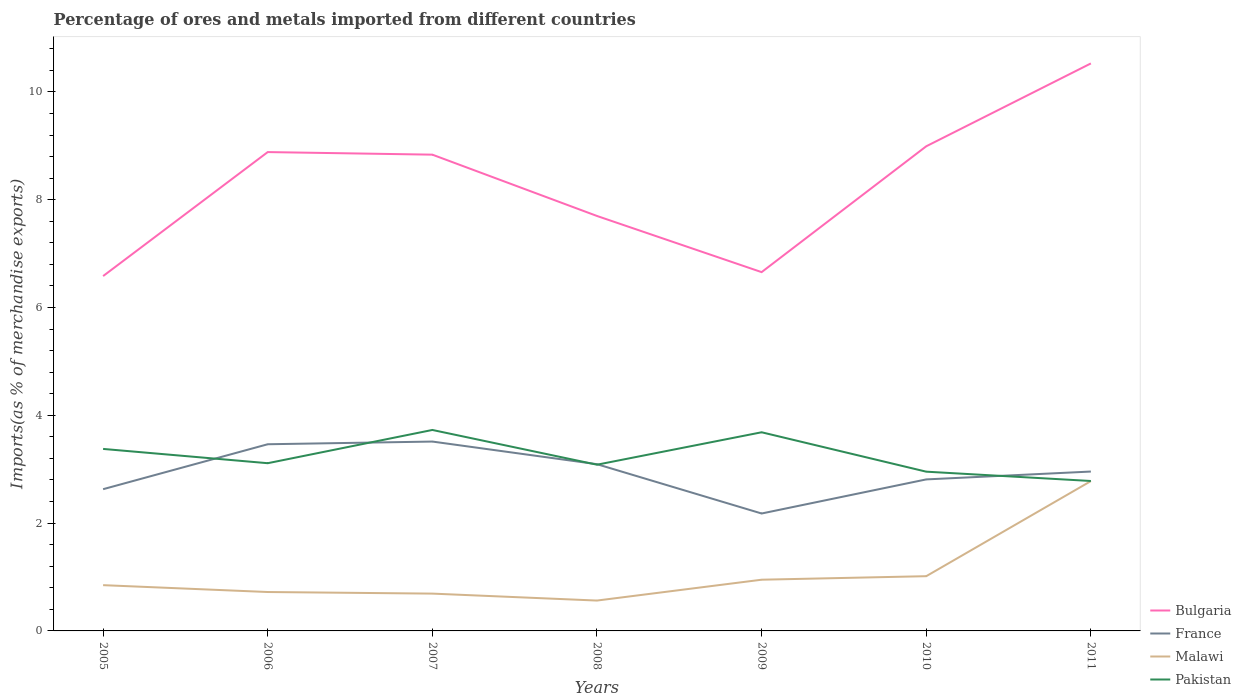How many different coloured lines are there?
Keep it short and to the point. 4. Across all years, what is the maximum percentage of imports to different countries in France?
Provide a succinct answer. 2.18. In which year was the percentage of imports to different countries in France maximum?
Make the answer very short. 2009. What is the total percentage of imports to different countries in France in the graph?
Ensure brevity in your answer.  0.37. What is the difference between the highest and the second highest percentage of imports to different countries in Bulgaria?
Provide a succinct answer. 3.94. Is the percentage of imports to different countries in Malawi strictly greater than the percentage of imports to different countries in Pakistan over the years?
Offer a terse response. Yes. How many lines are there?
Your answer should be compact. 4. How many years are there in the graph?
Your answer should be compact. 7. What is the difference between two consecutive major ticks on the Y-axis?
Your answer should be very brief. 2. Does the graph contain any zero values?
Give a very brief answer. No. How many legend labels are there?
Your answer should be compact. 4. How are the legend labels stacked?
Offer a very short reply. Vertical. What is the title of the graph?
Provide a short and direct response. Percentage of ores and metals imported from different countries. What is the label or title of the X-axis?
Make the answer very short. Years. What is the label or title of the Y-axis?
Offer a very short reply. Imports(as % of merchandise exports). What is the Imports(as % of merchandise exports) of Bulgaria in 2005?
Offer a terse response. 6.58. What is the Imports(as % of merchandise exports) of France in 2005?
Provide a succinct answer. 2.63. What is the Imports(as % of merchandise exports) in Malawi in 2005?
Offer a very short reply. 0.85. What is the Imports(as % of merchandise exports) of Pakistan in 2005?
Your answer should be compact. 3.38. What is the Imports(as % of merchandise exports) in Bulgaria in 2006?
Keep it short and to the point. 8.88. What is the Imports(as % of merchandise exports) of France in 2006?
Make the answer very short. 3.46. What is the Imports(as % of merchandise exports) of Malawi in 2006?
Offer a very short reply. 0.72. What is the Imports(as % of merchandise exports) of Pakistan in 2006?
Your answer should be very brief. 3.11. What is the Imports(as % of merchandise exports) in Bulgaria in 2007?
Offer a very short reply. 8.84. What is the Imports(as % of merchandise exports) of France in 2007?
Provide a succinct answer. 3.51. What is the Imports(as % of merchandise exports) in Malawi in 2007?
Ensure brevity in your answer.  0.69. What is the Imports(as % of merchandise exports) in Pakistan in 2007?
Keep it short and to the point. 3.73. What is the Imports(as % of merchandise exports) in Bulgaria in 2008?
Give a very brief answer. 7.7. What is the Imports(as % of merchandise exports) in France in 2008?
Give a very brief answer. 3.09. What is the Imports(as % of merchandise exports) of Malawi in 2008?
Offer a very short reply. 0.56. What is the Imports(as % of merchandise exports) of Pakistan in 2008?
Give a very brief answer. 3.08. What is the Imports(as % of merchandise exports) of Bulgaria in 2009?
Your response must be concise. 6.66. What is the Imports(as % of merchandise exports) in France in 2009?
Offer a terse response. 2.18. What is the Imports(as % of merchandise exports) in Malawi in 2009?
Keep it short and to the point. 0.95. What is the Imports(as % of merchandise exports) of Pakistan in 2009?
Ensure brevity in your answer.  3.69. What is the Imports(as % of merchandise exports) in Bulgaria in 2010?
Ensure brevity in your answer.  8.99. What is the Imports(as % of merchandise exports) in France in 2010?
Ensure brevity in your answer.  2.81. What is the Imports(as % of merchandise exports) of Malawi in 2010?
Provide a short and direct response. 1.02. What is the Imports(as % of merchandise exports) of Pakistan in 2010?
Offer a terse response. 2.95. What is the Imports(as % of merchandise exports) of Bulgaria in 2011?
Offer a terse response. 10.53. What is the Imports(as % of merchandise exports) of France in 2011?
Offer a terse response. 2.96. What is the Imports(as % of merchandise exports) in Malawi in 2011?
Your answer should be compact. 2.78. What is the Imports(as % of merchandise exports) in Pakistan in 2011?
Make the answer very short. 2.78. Across all years, what is the maximum Imports(as % of merchandise exports) in Bulgaria?
Your answer should be compact. 10.53. Across all years, what is the maximum Imports(as % of merchandise exports) in France?
Your answer should be compact. 3.51. Across all years, what is the maximum Imports(as % of merchandise exports) of Malawi?
Keep it short and to the point. 2.78. Across all years, what is the maximum Imports(as % of merchandise exports) in Pakistan?
Your response must be concise. 3.73. Across all years, what is the minimum Imports(as % of merchandise exports) in Bulgaria?
Offer a terse response. 6.58. Across all years, what is the minimum Imports(as % of merchandise exports) of France?
Offer a very short reply. 2.18. Across all years, what is the minimum Imports(as % of merchandise exports) in Malawi?
Ensure brevity in your answer.  0.56. Across all years, what is the minimum Imports(as % of merchandise exports) in Pakistan?
Provide a succinct answer. 2.78. What is the total Imports(as % of merchandise exports) of Bulgaria in the graph?
Your response must be concise. 58.18. What is the total Imports(as % of merchandise exports) in France in the graph?
Ensure brevity in your answer.  20.64. What is the total Imports(as % of merchandise exports) in Malawi in the graph?
Keep it short and to the point. 7.57. What is the total Imports(as % of merchandise exports) of Pakistan in the graph?
Give a very brief answer. 22.72. What is the difference between the Imports(as % of merchandise exports) in Bulgaria in 2005 and that in 2006?
Make the answer very short. -2.3. What is the difference between the Imports(as % of merchandise exports) in France in 2005 and that in 2006?
Provide a succinct answer. -0.83. What is the difference between the Imports(as % of merchandise exports) of Malawi in 2005 and that in 2006?
Your response must be concise. 0.13. What is the difference between the Imports(as % of merchandise exports) in Pakistan in 2005 and that in 2006?
Offer a terse response. 0.27. What is the difference between the Imports(as % of merchandise exports) of Bulgaria in 2005 and that in 2007?
Your answer should be compact. -2.25. What is the difference between the Imports(as % of merchandise exports) of France in 2005 and that in 2007?
Ensure brevity in your answer.  -0.88. What is the difference between the Imports(as % of merchandise exports) in Malawi in 2005 and that in 2007?
Ensure brevity in your answer.  0.16. What is the difference between the Imports(as % of merchandise exports) in Pakistan in 2005 and that in 2007?
Offer a very short reply. -0.35. What is the difference between the Imports(as % of merchandise exports) in Bulgaria in 2005 and that in 2008?
Your response must be concise. -1.11. What is the difference between the Imports(as % of merchandise exports) of France in 2005 and that in 2008?
Offer a very short reply. -0.46. What is the difference between the Imports(as % of merchandise exports) of Malawi in 2005 and that in 2008?
Keep it short and to the point. 0.29. What is the difference between the Imports(as % of merchandise exports) in Pakistan in 2005 and that in 2008?
Your answer should be compact. 0.29. What is the difference between the Imports(as % of merchandise exports) in Bulgaria in 2005 and that in 2009?
Provide a succinct answer. -0.07. What is the difference between the Imports(as % of merchandise exports) of France in 2005 and that in 2009?
Your answer should be very brief. 0.45. What is the difference between the Imports(as % of merchandise exports) of Malawi in 2005 and that in 2009?
Make the answer very short. -0.1. What is the difference between the Imports(as % of merchandise exports) in Pakistan in 2005 and that in 2009?
Keep it short and to the point. -0.31. What is the difference between the Imports(as % of merchandise exports) of Bulgaria in 2005 and that in 2010?
Your answer should be compact. -2.41. What is the difference between the Imports(as % of merchandise exports) in France in 2005 and that in 2010?
Offer a terse response. -0.18. What is the difference between the Imports(as % of merchandise exports) in Malawi in 2005 and that in 2010?
Provide a short and direct response. -0.17. What is the difference between the Imports(as % of merchandise exports) in Pakistan in 2005 and that in 2010?
Your answer should be very brief. 0.42. What is the difference between the Imports(as % of merchandise exports) of Bulgaria in 2005 and that in 2011?
Make the answer very short. -3.94. What is the difference between the Imports(as % of merchandise exports) of France in 2005 and that in 2011?
Keep it short and to the point. -0.33. What is the difference between the Imports(as % of merchandise exports) in Malawi in 2005 and that in 2011?
Ensure brevity in your answer.  -1.93. What is the difference between the Imports(as % of merchandise exports) of Pakistan in 2005 and that in 2011?
Provide a short and direct response. 0.59. What is the difference between the Imports(as % of merchandise exports) in Bulgaria in 2006 and that in 2007?
Your answer should be compact. 0.05. What is the difference between the Imports(as % of merchandise exports) in France in 2006 and that in 2007?
Offer a terse response. -0.05. What is the difference between the Imports(as % of merchandise exports) of Malawi in 2006 and that in 2007?
Make the answer very short. 0.03. What is the difference between the Imports(as % of merchandise exports) in Pakistan in 2006 and that in 2007?
Keep it short and to the point. -0.62. What is the difference between the Imports(as % of merchandise exports) in Bulgaria in 2006 and that in 2008?
Your answer should be compact. 1.19. What is the difference between the Imports(as % of merchandise exports) in France in 2006 and that in 2008?
Ensure brevity in your answer.  0.37. What is the difference between the Imports(as % of merchandise exports) in Malawi in 2006 and that in 2008?
Your response must be concise. 0.16. What is the difference between the Imports(as % of merchandise exports) of Pakistan in 2006 and that in 2008?
Offer a terse response. 0.03. What is the difference between the Imports(as % of merchandise exports) in Bulgaria in 2006 and that in 2009?
Your answer should be compact. 2.23. What is the difference between the Imports(as % of merchandise exports) in France in 2006 and that in 2009?
Make the answer very short. 1.28. What is the difference between the Imports(as % of merchandise exports) in Malawi in 2006 and that in 2009?
Your answer should be very brief. -0.23. What is the difference between the Imports(as % of merchandise exports) of Pakistan in 2006 and that in 2009?
Offer a terse response. -0.57. What is the difference between the Imports(as % of merchandise exports) of Bulgaria in 2006 and that in 2010?
Your answer should be very brief. -0.11. What is the difference between the Imports(as % of merchandise exports) in France in 2006 and that in 2010?
Your response must be concise. 0.65. What is the difference between the Imports(as % of merchandise exports) in Malawi in 2006 and that in 2010?
Keep it short and to the point. -0.29. What is the difference between the Imports(as % of merchandise exports) of Pakistan in 2006 and that in 2010?
Give a very brief answer. 0.16. What is the difference between the Imports(as % of merchandise exports) of Bulgaria in 2006 and that in 2011?
Your response must be concise. -1.64. What is the difference between the Imports(as % of merchandise exports) in France in 2006 and that in 2011?
Offer a terse response. 0.51. What is the difference between the Imports(as % of merchandise exports) in Malawi in 2006 and that in 2011?
Ensure brevity in your answer.  -2.06. What is the difference between the Imports(as % of merchandise exports) in Pakistan in 2006 and that in 2011?
Make the answer very short. 0.33. What is the difference between the Imports(as % of merchandise exports) in Bulgaria in 2007 and that in 2008?
Provide a succinct answer. 1.14. What is the difference between the Imports(as % of merchandise exports) of France in 2007 and that in 2008?
Offer a terse response. 0.42. What is the difference between the Imports(as % of merchandise exports) in Malawi in 2007 and that in 2008?
Make the answer very short. 0.13. What is the difference between the Imports(as % of merchandise exports) of Pakistan in 2007 and that in 2008?
Your answer should be compact. 0.64. What is the difference between the Imports(as % of merchandise exports) of Bulgaria in 2007 and that in 2009?
Provide a short and direct response. 2.18. What is the difference between the Imports(as % of merchandise exports) of France in 2007 and that in 2009?
Give a very brief answer. 1.33. What is the difference between the Imports(as % of merchandise exports) in Malawi in 2007 and that in 2009?
Make the answer very short. -0.26. What is the difference between the Imports(as % of merchandise exports) of Pakistan in 2007 and that in 2009?
Provide a short and direct response. 0.04. What is the difference between the Imports(as % of merchandise exports) of Bulgaria in 2007 and that in 2010?
Offer a very short reply. -0.16. What is the difference between the Imports(as % of merchandise exports) of France in 2007 and that in 2010?
Provide a short and direct response. 0.7. What is the difference between the Imports(as % of merchandise exports) of Malawi in 2007 and that in 2010?
Offer a terse response. -0.32. What is the difference between the Imports(as % of merchandise exports) of Pakistan in 2007 and that in 2010?
Offer a very short reply. 0.77. What is the difference between the Imports(as % of merchandise exports) of Bulgaria in 2007 and that in 2011?
Your answer should be compact. -1.69. What is the difference between the Imports(as % of merchandise exports) of France in 2007 and that in 2011?
Keep it short and to the point. 0.56. What is the difference between the Imports(as % of merchandise exports) in Malawi in 2007 and that in 2011?
Your answer should be very brief. -2.09. What is the difference between the Imports(as % of merchandise exports) of Pakistan in 2007 and that in 2011?
Give a very brief answer. 0.95. What is the difference between the Imports(as % of merchandise exports) of Bulgaria in 2008 and that in 2009?
Provide a short and direct response. 1.04. What is the difference between the Imports(as % of merchandise exports) of France in 2008 and that in 2009?
Offer a very short reply. 0.91. What is the difference between the Imports(as % of merchandise exports) in Malawi in 2008 and that in 2009?
Keep it short and to the point. -0.39. What is the difference between the Imports(as % of merchandise exports) in Pakistan in 2008 and that in 2009?
Give a very brief answer. -0.6. What is the difference between the Imports(as % of merchandise exports) in Bulgaria in 2008 and that in 2010?
Offer a terse response. -1.29. What is the difference between the Imports(as % of merchandise exports) in France in 2008 and that in 2010?
Give a very brief answer. 0.28. What is the difference between the Imports(as % of merchandise exports) of Malawi in 2008 and that in 2010?
Ensure brevity in your answer.  -0.45. What is the difference between the Imports(as % of merchandise exports) of Pakistan in 2008 and that in 2010?
Provide a succinct answer. 0.13. What is the difference between the Imports(as % of merchandise exports) of Bulgaria in 2008 and that in 2011?
Your answer should be very brief. -2.83. What is the difference between the Imports(as % of merchandise exports) of France in 2008 and that in 2011?
Keep it short and to the point. 0.14. What is the difference between the Imports(as % of merchandise exports) in Malawi in 2008 and that in 2011?
Give a very brief answer. -2.22. What is the difference between the Imports(as % of merchandise exports) in Pakistan in 2008 and that in 2011?
Keep it short and to the point. 0.3. What is the difference between the Imports(as % of merchandise exports) of Bulgaria in 2009 and that in 2010?
Make the answer very short. -2.33. What is the difference between the Imports(as % of merchandise exports) of France in 2009 and that in 2010?
Give a very brief answer. -0.63. What is the difference between the Imports(as % of merchandise exports) of Malawi in 2009 and that in 2010?
Offer a terse response. -0.07. What is the difference between the Imports(as % of merchandise exports) of Pakistan in 2009 and that in 2010?
Offer a very short reply. 0.73. What is the difference between the Imports(as % of merchandise exports) in Bulgaria in 2009 and that in 2011?
Make the answer very short. -3.87. What is the difference between the Imports(as % of merchandise exports) in France in 2009 and that in 2011?
Provide a succinct answer. -0.78. What is the difference between the Imports(as % of merchandise exports) of Malawi in 2009 and that in 2011?
Offer a very short reply. -1.83. What is the difference between the Imports(as % of merchandise exports) in Pakistan in 2009 and that in 2011?
Your answer should be very brief. 0.9. What is the difference between the Imports(as % of merchandise exports) of Bulgaria in 2010 and that in 2011?
Provide a short and direct response. -1.54. What is the difference between the Imports(as % of merchandise exports) of France in 2010 and that in 2011?
Give a very brief answer. -0.15. What is the difference between the Imports(as % of merchandise exports) in Malawi in 2010 and that in 2011?
Your response must be concise. -1.76. What is the difference between the Imports(as % of merchandise exports) in Pakistan in 2010 and that in 2011?
Offer a terse response. 0.17. What is the difference between the Imports(as % of merchandise exports) in Bulgaria in 2005 and the Imports(as % of merchandise exports) in France in 2006?
Offer a terse response. 3.12. What is the difference between the Imports(as % of merchandise exports) in Bulgaria in 2005 and the Imports(as % of merchandise exports) in Malawi in 2006?
Provide a succinct answer. 5.86. What is the difference between the Imports(as % of merchandise exports) of Bulgaria in 2005 and the Imports(as % of merchandise exports) of Pakistan in 2006?
Your answer should be very brief. 3.47. What is the difference between the Imports(as % of merchandise exports) in France in 2005 and the Imports(as % of merchandise exports) in Malawi in 2006?
Your answer should be compact. 1.91. What is the difference between the Imports(as % of merchandise exports) of France in 2005 and the Imports(as % of merchandise exports) of Pakistan in 2006?
Your response must be concise. -0.48. What is the difference between the Imports(as % of merchandise exports) of Malawi in 2005 and the Imports(as % of merchandise exports) of Pakistan in 2006?
Your response must be concise. -2.26. What is the difference between the Imports(as % of merchandise exports) in Bulgaria in 2005 and the Imports(as % of merchandise exports) in France in 2007?
Make the answer very short. 3.07. What is the difference between the Imports(as % of merchandise exports) of Bulgaria in 2005 and the Imports(as % of merchandise exports) of Malawi in 2007?
Give a very brief answer. 5.89. What is the difference between the Imports(as % of merchandise exports) in Bulgaria in 2005 and the Imports(as % of merchandise exports) in Pakistan in 2007?
Make the answer very short. 2.85. What is the difference between the Imports(as % of merchandise exports) in France in 2005 and the Imports(as % of merchandise exports) in Malawi in 2007?
Offer a very short reply. 1.94. What is the difference between the Imports(as % of merchandise exports) in France in 2005 and the Imports(as % of merchandise exports) in Pakistan in 2007?
Keep it short and to the point. -1.1. What is the difference between the Imports(as % of merchandise exports) of Malawi in 2005 and the Imports(as % of merchandise exports) of Pakistan in 2007?
Ensure brevity in your answer.  -2.88. What is the difference between the Imports(as % of merchandise exports) of Bulgaria in 2005 and the Imports(as % of merchandise exports) of France in 2008?
Your answer should be very brief. 3.49. What is the difference between the Imports(as % of merchandise exports) of Bulgaria in 2005 and the Imports(as % of merchandise exports) of Malawi in 2008?
Your answer should be very brief. 6.02. What is the difference between the Imports(as % of merchandise exports) of Bulgaria in 2005 and the Imports(as % of merchandise exports) of Pakistan in 2008?
Your response must be concise. 3.5. What is the difference between the Imports(as % of merchandise exports) in France in 2005 and the Imports(as % of merchandise exports) in Malawi in 2008?
Offer a very short reply. 2.07. What is the difference between the Imports(as % of merchandise exports) of France in 2005 and the Imports(as % of merchandise exports) of Pakistan in 2008?
Give a very brief answer. -0.45. What is the difference between the Imports(as % of merchandise exports) of Malawi in 2005 and the Imports(as % of merchandise exports) of Pakistan in 2008?
Offer a terse response. -2.23. What is the difference between the Imports(as % of merchandise exports) in Bulgaria in 2005 and the Imports(as % of merchandise exports) in France in 2009?
Provide a short and direct response. 4.4. What is the difference between the Imports(as % of merchandise exports) in Bulgaria in 2005 and the Imports(as % of merchandise exports) in Malawi in 2009?
Ensure brevity in your answer.  5.63. What is the difference between the Imports(as % of merchandise exports) of Bulgaria in 2005 and the Imports(as % of merchandise exports) of Pakistan in 2009?
Offer a terse response. 2.9. What is the difference between the Imports(as % of merchandise exports) in France in 2005 and the Imports(as % of merchandise exports) in Malawi in 2009?
Offer a very short reply. 1.68. What is the difference between the Imports(as % of merchandise exports) of France in 2005 and the Imports(as % of merchandise exports) of Pakistan in 2009?
Ensure brevity in your answer.  -1.06. What is the difference between the Imports(as % of merchandise exports) in Malawi in 2005 and the Imports(as % of merchandise exports) in Pakistan in 2009?
Your answer should be compact. -2.84. What is the difference between the Imports(as % of merchandise exports) of Bulgaria in 2005 and the Imports(as % of merchandise exports) of France in 2010?
Ensure brevity in your answer.  3.77. What is the difference between the Imports(as % of merchandise exports) in Bulgaria in 2005 and the Imports(as % of merchandise exports) in Malawi in 2010?
Your response must be concise. 5.57. What is the difference between the Imports(as % of merchandise exports) of Bulgaria in 2005 and the Imports(as % of merchandise exports) of Pakistan in 2010?
Your answer should be compact. 3.63. What is the difference between the Imports(as % of merchandise exports) of France in 2005 and the Imports(as % of merchandise exports) of Malawi in 2010?
Provide a short and direct response. 1.61. What is the difference between the Imports(as % of merchandise exports) in France in 2005 and the Imports(as % of merchandise exports) in Pakistan in 2010?
Give a very brief answer. -0.32. What is the difference between the Imports(as % of merchandise exports) of Malawi in 2005 and the Imports(as % of merchandise exports) of Pakistan in 2010?
Your answer should be compact. -2.11. What is the difference between the Imports(as % of merchandise exports) in Bulgaria in 2005 and the Imports(as % of merchandise exports) in France in 2011?
Provide a short and direct response. 3.63. What is the difference between the Imports(as % of merchandise exports) of Bulgaria in 2005 and the Imports(as % of merchandise exports) of Malawi in 2011?
Your response must be concise. 3.8. What is the difference between the Imports(as % of merchandise exports) in Bulgaria in 2005 and the Imports(as % of merchandise exports) in Pakistan in 2011?
Provide a succinct answer. 3.8. What is the difference between the Imports(as % of merchandise exports) in France in 2005 and the Imports(as % of merchandise exports) in Malawi in 2011?
Give a very brief answer. -0.15. What is the difference between the Imports(as % of merchandise exports) in France in 2005 and the Imports(as % of merchandise exports) in Pakistan in 2011?
Your answer should be very brief. -0.15. What is the difference between the Imports(as % of merchandise exports) of Malawi in 2005 and the Imports(as % of merchandise exports) of Pakistan in 2011?
Provide a short and direct response. -1.93. What is the difference between the Imports(as % of merchandise exports) in Bulgaria in 2006 and the Imports(as % of merchandise exports) in France in 2007?
Your answer should be compact. 5.37. What is the difference between the Imports(as % of merchandise exports) of Bulgaria in 2006 and the Imports(as % of merchandise exports) of Malawi in 2007?
Keep it short and to the point. 8.19. What is the difference between the Imports(as % of merchandise exports) of Bulgaria in 2006 and the Imports(as % of merchandise exports) of Pakistan in 2007?
Make the answer very short. 5.16. What is the difference between the Imports(as % of merchandise exports) in France in 2006 and the Imports(as % of merchandise exports) in Malawi in 2007?
Offer a terse response. 2.77. What is the difference between the Imports(as % of merchandise exports) of France in 2006 and the Imports(as % of merchandise exports) of Pakistan in 2007?
Offer a terse response. -0.27. What is the difference between the Imports(as % of merchandise exports) of Malawi in 2006 and the Imports(as % of merchandise exports) of Pakistan in 2007?
Make the answer very short. -3.01. What is the difference between the Imports(as % of merchandise exports) of Bulgaria in 2006 and the Imports(as % of merchandise exports) of France in 2008?
Your answer should be very brief. 5.79. What is the difference between the Imports(as % of merchandise exports) of Bulgaria in 2006 and the Imports(as % of merchandise exports) of Malawi in 2008?
Offer a very short reply. 8.32. What is the difference between the Imports(as % of merchandise exports) in Bulgaria in 2006 and the Imports(as % of merchandise exports) in Pakistan in 2008?
Your answer should be very brief. 5.8. What is the difference between the Imports(as % of merchandise exports) in France in 2006 and the Imports(as % of merchandise exports) in Malawi in 2008?
Ensure brevity in your answer.  2.9. What is the difference between the Imports(as % of merchandise exports) in France in 2006 and the Imports(as % of merchandise exports) in Pakistan in 2008?
Make the answer very short. 0.38. What is the difference between the Imports(as % of merchandise exports) in Malawi in 2006 and the Imports(as % of merchandise exports) in Pakistan in 2008?
Give a very brief answer. -2.36. What is the difference between the Imports(as % of merchandise exports) of Bulgaria in 2006 and the Imports(as % of merchandise exports) of France in 2009?
Your answer should be very brief. 6.71. What is the difference between the Imports(as % of merchandise exports) of Bulgaria in 2006 and the Imports(as % of merchandise exports) of Malawi in 2009?
Offer a very short reply. 7.93. What is the difference between the Imports(as % of merchandise exports) of Bulgaria in 2006 and the Imports(as % of merchandise exports) of Pakistan in 2009?
Your answer should be very brief. 5.2. What is the difference between the Imports(as % of merchandise exports) of France in 2006 and the Imports(as % of merchandise exports) of Malawi in 2009?
Your response must be concise. 2.51. What is the difference between the Imports(as % of merchandise exports) of France in 2006 and the Imports(as % of merchandise exports) of Pakistan in 2009?
Make the answer very short. -0.22. What is the difference between the Imports(as % of merchandise exports) of Malawi in 2006 and the Imports(as % of merchandise exports) of Pakistan in 2009?
Your response must be concise. -2.96. What is the difference between the Imports(as % of merchandise exports) of Bulgaria in 2006 and the Imports(as % of merchandise exports) of France in 2010?
Provide a short and direct response. 6.07. What is the difference between the Imports(as % of merchandise exports) of Bulgaria in 2006 and the Imports(as % of merchandise exports) of Malawi in 2010?
Provide a succinct answer. 7.87. What is the difference between the Imports(as % of merchandise exports) of Bulgaria in 2006 and the Imports(as % of merchandise exports) of Pakistan in 2010?
Your response must be concise. 5.93. What is the difference between the Imports(as % of merchandise exports) in France in 2006 and the Imports(as % of merchandise exports) in Malawi in 2010?
Your answer should be very brief. 2.45. What is the difference between the Imports(as % of merchandise exports) in France in 2006 and the Imports(as % of merchandise exports) in Pakistan in 2010?
Keep it short and to the point. 0.51. What is the difference between the Imports(as % of merchandise exports) in Malawi in 2006 and the Imports(as % of merchandise exports) in Pakistan in 2010?
Keep it short and to the point. -2.23. What is the difference between the Imports(as % of merchandise exports) in Bulgaria in 2006 and the Imports(as % of merchandise exports) in France in 2011?
Provide a succinct answer. 5.93. What is the difference between the Imports(as % of merchandise exports) of Bulgaria in 2006 and the Imports(as % of merchandise exports) of Malawi in 2011?
Provide a succinct answer. 6.1. What is the difference between the Imports(as % of merchandise exports) of Bulgaria in 2006 and the Imports(as % of merchandise exports) of Pakistan in 2011?
Ensure brevity in your answer.  6.1. What is the difference between the Imports(as % of merchandise exports) of France in 2006 and the Imports(as % of merchandise exports) of Malawi in 2011?
Your answer should be compact. 0.68. What is the difference between the Imports(as % of merchandise exports) of France in 2006 and the Imports(as % of merchandise exports) of Pakistan in 2011?
Provide a succinct answer. 0.68. What is the difference between the Imports(as % of merchandise exports) in Malawi in 2006 and the Imports(as % of merchandise exports) in Pakistan in 2011?
Ensure brevity in your answer.  -2.06. What is the difference between the Imports(as % of merchandise exports) in Bulgaria in 2007 and the Imports(as % of merchandise exports) in France in 2008?
Ensure brevity in your answer.  5.74. What is the difference between the Imports(as % of merchandise exports) of Bulgaria in 2007 and the Imports(as % of merchandise exports) of Malawi in 2008?
Offer a terse response. 8.27. What is the difference between the Imports(as % of merchandise exports) of Bulgaria in 2007 and the Imports(as % of merchandise exports) of Pakistan in 2008?
Ensure brevity in your answer.  5.75. What is the difference between the Imports(as % of merchandise exports) in France in 2007 and the Imports(as % of merchandise exports) in Malawi in 2008?
Keep it short and to the point. 2.95. What is the difference between the Imports(as % of merchandise exports) in France in 2007 and the Imports(as % of merchandise exports) in Pakistan in 2008?
Provide a succinct answer. 0.43. What is the difference between the Imports(as % of merchandise exports) of Malawi in 2007 and the Imports(as % of merchandise exports) of Pakistan in 2008?
Ensure brevity in your answer.  -2.39. What is the difference between the Imports(as % of merchandise exports) of Bulgaria in 2007 and the Imports(as % of merchandise exports) of France in 2009?
Your response must be concise. 6.66. What is the difference between the Imports(as % of merchandise exports) of Bulgaria in 2007 and the Imports(as % of merchandise exports) of Malawi in 2009?
Provide a succinct answer. 7.89. What is the difference between the Imports(as % of merchandise exports) in Bulgaria in 2007 and the Imports(as % of merchandise exports) in Pakistan in 2009?
Provide a succinct answer. 5.15. What is the difference between the Imports(as % of merchandise exports) of France in 2007 and the Imports(as % of merchandise exports) of Malawi in 2009?
Your answer should be compact. 2.56. What is the difference between the Imports(as % of merchandise exports) in France in 2007 and the Imports(as % of merchandise exports) in Pakistan in 2009?
Ensure brevity in your answer.  -0.17. What is the difference between the Imports(as % of merchandise exports) of Malawi in 2007 and the Imports(as % of merchandise exports) of Pakistan in 2009?
Offer a very short reply. -2.99. What is the difference between the Imports(as % of merchandise exports) in Bulgaria in 2007 and the Imports(as % of merchandise exports) in France in 2010?
Give a very brief answer. 6.02. What is the difference between the Imports(as % of merchandise exports) of Bulgaria in 2007 and the Imports(as % of merchandise exports) of Malawi in 2010?
Keep it short and to the point. 7.82. What is the difference between the Imports(as % of merchandise exports) in Bulgaria in 2007 and the Imports(as % of merchandise exports) in Pakistan in 2010?
Your answer should be very brief. 5.88. What is the difference between the Imports(as % of merchandise exports) in France in 2007 and the Imports(as % of merchandise exports) in Malawi in 2010?
Your answer should be very brief. 2.5. What is the difference between the Imports(as % of merchandise exports) in France in 2007 and the Imports(as % of merchandise exports) in Pakistan in 2010?
Give a very brief answer. 0.56. What is the difference between the Imports(as % of merchandise exports) of Malawi in 2007 and the Imports(as % of merchandise exports) of Pakistan in 2010?
Keep it short and to the point. -2.26. What is the difference between the Imports(as % of merchandise exports) in Bulgaria in 2007 and the Imports(as % of merchandise exports) in France in 2011?
Your response must be concise. 5.88. What is the difference between the Imports(as % of merchandise exports) in Bulgaria in 2007 and the Imports(as % of merchandise exports) in Malawi in 2011?
Offer a very short reply. 6.06. What is the difference between the Imports(as % of merchandise exports) of Bulgaria in 2007 and the Imports(as % of merchandise exports) of Pakistan in 2011?
Ensure brevity in your answer.  6.05. What is the difference between the Imports(as % of merchandise exports) in France in 2007 and the Imports(as % of merchandise exports) in Malawi in 2011?
Your answer should be very brief. 0.73. What is the difference between the Imports(as % of merchandise exports) in France in 2007 and the Imports(as % of merchandise exports) in Pakistan in 2011?
Your response must be concise. 0.73. What is the difference between the Imports(as % of merchandise exports) of Malawi in 2007 and the Imports(as % of merchandise exports) of Pakistan in 2011?
Offer a terse response. -2.09. What is the difference between the Imports(as % of merchandise exports) in Bulgaria in 2008 and the Imports(as % of merchandise exports) in France in 2009?
Offer a terse response. 5.52. What is the difference between the Imports(as % of merchandise exports) in Bulgaria in 2008 and the Imports(as % of merchandise exports) in Malawi in 2009?
Your response must be concise. 6.75. What is the difference between the Imports(as % of merchandise exports) of Bulgaria in 2008 and the Imports(as % of merchandise exports) of Pakistan in 2009?
Make the answer very short. 4.01. What is the difference between the Imports(as % of merchandise exports) of France in 2008 and the Imports(as % of merchandise exports) of Malawi in 2009?
Your answer should be very brief. 2.14. What is the difference between the Imports(as % of merchandise exports) of France in 2008 and the Imports(as % of merchandise exports) of Pakistan in 2009?
Your response must be concise. -0.59. What is the difference between the Imports(as % of merchandise exports) in Malawi in 2008 and the Imports(as % of merchandise exports) in Pakistan in 2009?
Provide a short and direct response. -3.12. What is the difference between the Imports(as % of merchandise exports) of Bulgaria in 2008 and the Imports(as % of merchandise exports) of France in 2010?
Offer a very short reply. 4.89. What is the difference between the Imports(as % of merchandise exports) of Bulgaria in 2008 and the Imports(as % of merchandise exports) of Malawi in 2010?
Offer a very short reply. 6.68. What is the difference between the Imports(as % of merchandise exports) of Bulgaria in 2008 and the Imports(as % of merchandise exports) of Pakistan in 2010?
Make the answer very short. 4.74. What is the difference between the Imports(as % of merchandise exports) in France in 2008 and the Imports(as % of merchandise exports) in Malawi in 2010?
Your answer should be compact. 2.08. What is the difference between the Imports(as % of merchandise exports) in France in 2008 and the Imports(as % of merchandise exports) in Pakistan in 2010?
Give a very brief answer. 0.14. What is the difference between the Imports(as % of merchandise exports) of Malawi in 2008 and the Imports(as % of merchandise exports) of Pakistan in 2010?
Provide a succinct answer. -2.39. What is the difference between the Imports(as % of merchandise exports) in Bulgaria in 2008 and the Imports(as % of merchandise exports) in France in 2011?
Offer a very short reply. 4.74. What is the difference between the Imports(as % of merchandise exports) in Bulgaria in 2008 and the Imports(as % of merchandise exports) in Malawi in 2011?
Your answer should be compact. 4.92. What is the difference between the Imports(as % of merchandise exports) of Bulgaria in 2008 and the Imports(as % of merchandise exports) of Pakistan in 2011?
Provide a succinct answer. 4.92. What is the difference between the Imports(as % of merchandise exports) in France in 2008 and the Imports(as % of merchandise exports) in Malawi in 2011?
Your answer should be very brief. 0.31. What is the difference between the Imports(as % of merchandise exports) of France in 2008 and the Imports(as % of merchandise exports) of Pakistan in 2011?
Your answer should be very brief. 0.31. What is the difference between the Imports(as % of merchandise exports) in Malawi in 2008 and the Imports(as % of merchandise exports) in Pakistan in 2011?
Ensure brevity in your answer.  -2.22. What is the difference between the Imports(as % of merchandise exports) of Bulgaria in 2009 and the Imports(as % of merchandise exports) of France in 2010?
Keep it short and to the point. 3.85. What is the difference between the Imports(as % of merchandise exports) of Bulgaria in 2009 and the Imports(as % of merchandise exports) of Malawi in 2010?
Your answer should be compact. 5.64. What is the difference between the Imports(as % of merchandise exports) in Bulgaria in 2009 and the Imports(as % of merchandise exports) in Pakistan in 2010?
Provide a succinct answer. 3.7. What is the difference between the Imports(as % of merchandise exports) of France in 2009 and the Imports(as % of merchandise exports) of Malawi in 2010?
Your answer should be compact. 1.16. What is the difference between the Imports(as % of merchandise exports) in France in 2009 and the Imports(as % of merchandise exports) in Pakistan in 2010?
Your answer should be compact. -0.78. What is the difference between the Imports(as % of merchandise exports) of Malawi in 2009 and the Imports(as % of merchandise exports) of Pakistan in 2010?
Your response must be concise. -2. What is the difference between the Imports(as % of merchandise exports) in Bulgaria in 2009 and the Imports(as % of merchandise exports) in France in 2011?
Offer a very short reply. 3.7. What is the difference between the Imports(as % of merchandise exports) of Bulgaria in 2009 and the Imports(as % of merchandise exports) of Malawi in 2011?
Provide a short and direct response. 3.88. What is the difference between the Imports(as % of merchandise exports) in Bulgaria in 2009 and the Imports(as % of merchandise exports) in Pakistan in 2011?
Ensure brevity in your answer.  3.87. What is the difference between the Imports(as % of merchandise exports) of France in 2009 and the Imports(as % of merchandise exports) of Malawi in 2011?
Your answer should be very brief. -0.6. What is the difference between the Imports(as % of merchandise exports) of France in 2009 and the Imports(as % of merchandise exports) of Pakistan in 2011?
Make the answer very short. -0.6. What is the difference between the Imports(as % of merchandise exports) in Malawi in 2009 and the Imports(as % of merchandise exports) in Pakistan in 2011?
Provide a short and direct response. -1.83. What is the difference between the Imports(as % of merchandise exports) in Bulgaria in 2010 and the Imports(as % of merchandise exports) in France in 2011?
Ensure brevity in your answer.  6.03. What is the difference between the Imports(as % of merchandise exports) in Bulgaria in 2010 and the Imports(as % of merchandise exports) in Malawi in 2011?
Your answer should be compact. 6.21. What is the difference between the Imports(as % of merchandise exports) in Bulgaria in 2010 and the Imports(as % of merchandise exports) in Pakistan in 2011?
Offer a terse response. 6.21. What is the difference between the Imports(as % of merchandise exports) of France in 2010 and the Imports(as % of merchandise exports) of Malawi in 2011?
Your response must be concise. 0.03. What is the difference between the Imports(as % of merchandise exports) of France in 2010 and the Imports(as % of merchandise exports) of Pakistan in 2011?
Provide a succinct answer. 0.03. What is the difference between the Imports(as % of merchandise exports) of Malawi in 2010 and the Imports(as % of merchandise exports) of Pakistan in 2011?
Give a very brief answer. -1.77. What is the average Imports(as % of merchandise exports) of Bulgaria per year?
Ensure brevity in your answer.  8.31. What is the average Imports(as % of merchandise exports) in France per year?
Give a very brief answer. 2.95. What is the average Imports(as % of merchandise exports) in Malawi per year?
Make the answer very short. 1.08. What is the average Imports(as % of merchandise exports) of Pakistan per year?
Your response must be concise. 3.25. In the year 2005, what is the difference between the Imports(as % of merchandise exports) in Bulgaria and Imports(as % of merchandise exports) in France?
Ensure brevity in your answer.  3.95. In the year 2005, what is the difference between the Imports(as % of merchandise exports) in Bulgaria and Imports(as % of merchandise exports) in Malawi?
Provide a short and direct response. 5.73. In the year 2005, what is the difference between the Imports(as % of merchandise exports) of Bulgaria and Imports(as % of merchandise exports) of Pakistan?
Provide a succinct answer. 3.21. In the year 2005, what is the difference between the Imports(as % of merchandise exports) of France and Imports(as % of merchandise exports) of Malawi?
Provide a succinct answer. 1.78. In the year 2005, what is the difference between the Imports(as % of merchandise exports) of France and Imports(as % of merchandise exports) of Pakistan?
Your answer should be compact. -0.75. In the year 2005, what is the difference between the Imports(as % of merchandise exports) of Malawi and Imports(as % of merchandise exports) of Pakistan?
Give a very brief answer. -2.53. In the year 2006, what is the difference between the Imports(as % of merchandise exports) of Bulgaria and Imports(as % of merchandise exports) of France?
Your answer should be compact. 5.42. In the year 2006, what is the difference between the Imports(as % of merchandise exports) of Bulgaria and Imports(as % of merchandise exports) of Malawi?
Your response must be concise. 8.16. In the year 2006, what is the difference between the Imports(as % of merchandise exports) in Bulgaria and Imports(as % of merchandise exports) in Pakistan?
Keep it short and to the point. 5.77. In the year 2006, what is the difference between the Imports(as % of merchandise exports) in France and Imports(as % of merchandise exports) in Malawi?
Your response must be concise. 2.74. In the year 2006, what is the difference between the Imports(as % of merchandise exports) of France and Imports(as % of merchandise exports) of Pakistan?
Make the answer very short. 0.35. In the year 2006, what is the difference between the Imports(as % of merchandise exports) of Malawi and Imports(as % of merchandise exports) of Pakistan?
Provide a short and direct response. -2.39. In the year 2007, what is the difference between the Imports(as % of merchandise exports) of Bulgaria and Imports(as % of merchandise exports) of France?
Ensure brevity in your answer.  5.32. In the year 2007, what is the difference between the Imports(as % of merchandise exports) in Bulgaria and Imports(as % of merchandise exports) in Malawi?
Your response must be concise. 8.14. In the year 2007, what is the difference between the Imports(as % of merchandise exports) of Bulgaria and Imports(as % of merchandise exports) of Pakistan?
Your answer should be very brief. 5.11. In the year 2007, what is the difference between the Imports(as % of merchandise exports) of France and Imports(as % of merchandise exports) of Malawi?
Offer a terse response. 2.82. In the year 2007, what is the difference between the Imports(as % of merchandise exports) in France and Imports(as % of merchandise exports) in Pakistan?
Offer a terse response. -0.22. In the year 2007, what is the difference between the Imports(as % of merchandise exports) of Malawi and Imports(as % of merchandise exports) of Pakistan?
Give a very brief answer. -3.04. In the year 2008, what is the difference between the Imports(as % of merchandise exports) of Bulgaria and Imports(as % of merchandise exports) of France?
Ensure brevity in your answer.  4.6. In the year 2008, what is the difference between the Imports(as % of merchandise exports) in Bulgaria and Imports(as % of merchandise exports) in Malawi?
Ensure brevity in your answer.  7.13. In the year 2008, what is the difference between the Imports(as % of merchandise exports) of Bulgaria and Imports(as % of merchandise exports) of Pakistan?
Make the answer very short. 4.61. In the year 2008, what is the difference between the Imports(as % of merchandise exports) of France and Imports(as % of merchandise exports) of Malawi?
Give a very brief answer. 2.53. In the year 2008, what is the difference between the Imports(as % of merchandise exports) of France and Imports(as % of merchandise exports) of Pakistan?
Offer a very short reply. 0.01. In the year 2008, what is the difference between the Imports(as % of merchandise exports) in Malawi and Imports(as % of merchandise exports) in Pakistan?
Provide a short and direct response. -2.52. In the year 2009, what is the difference between the Imports(as % of merchandise exports) in Bulgaria and Imports(as % of merchandise exports) in France?
Ensure brevity in your answer.  4.48. In the year 2009, what is the difference between the Imports(as % of merchandise exports) of Bulgaria and Imports(as % of merchandise exports) of Malawi?
Give a very brief answer. 5.71. In the year 2009, what is the difference between the Imports(as % of merchandise exports) of Bulgaria and Imports(as % of merchandise exports) of Pakistan?
Provide a short and direct response. 2.97. In the year 2009, what is the difference between the Imports(as % of merchandise exports) of France and Imports(as % of merchandise exports) of Malawi?
Ensure brevity in your answer.  1.23. In the year 2009, what is the difference between the Imports(as % of merchandise exports) of France and Imports(as % of merchandise exports) of Pakistan?
Your answer should be compact. -1.51. In the year 2009, what is the difference between the Imports(as % of merchandise exports) of Malawi and Imports(as % of merchandise exports) of Pakistan?
Offer a very short reply. -2.74. In the year 2010, what is the difference between the Imports(as % of merchandise exports) of Bulgaria and Imports(as % of merchandise exports) of France?
Keep it short and to the point. 6.18. In the year 2010, what is the difference between the Imports(as % of merchandise exports) in Bulgaria and Imports(as % of merchandise exports) in Malawi?
Offer a terse response. 7.98. In the year 2010, what is the difference between the Imports(as % of merchandise exports) of Bulgaria and Imports(as % of merchandise exports) of Pakistan?
Provide a succinct answer. 6.04. In the year 2010, what is the difference between the Imports(as % of merchandise exports) of France and Imports(as % of merchandise exports) of Malawi?
Provide a short and direct response. 1.8. In the year 2010, what is the difference between the Imports(as % of merchandise exports) of France and Imports(as % of merchandise exports) of Pakistan?
Give a very brief answer. -0.14. In the year 2010, what is the difference between the Imports(as % of merchandise exports) in Malawi and Imports(as % of merchandise exports) in Pakistan?
Provide a short and direct response. -1.94. In the year 2011, what is the difference between the Imports(as % of merchandise exports) of Bulgaria and Imports(as % of merchandise exports) of France?
Ensure brevity in your answer.  7.57. In the year 2011, what is the difference between the Imports(as % of merchandise exports) of Bulgaria and Imports(as % of merchandise exports) of Malawi?
Make the answer very short. 7.75. In the year 2011, what is the difference between the Imports(as % of merchandise exports) of Bulgaria and Imports(as % of merchandise exports) of Pakistan?
Keep it short and to the point. 7.75. In the year 2011, what is the difference between the Imports(as % of merchandise exports) in France and Imports(as % of merchandise exports) in Malawi?
Ensure brevity in your answer.  0.18. In the year 2011, what is the difference between the Imports(as % of merchandise exports) of France and Imports(as % of merchandise exports) of Pakistan?
Keep it short and to the point. 0.18. In the year 2011, what is the difference between the Imports(as % of merchandise exports) in Malawi and Imports(as % of merchandise exports) in Pakistan?
Keep it short and to the point. -0. What is the ratio of the Imports(as % of merchandise exports) of Bulgaria in 2005 to that in 2006?
Make the answer very short. 0.74. What is the ratio of the Imports(as % of merchandise exports) of France in 2005 to that in 2006?
Offer a terse response. 0.76. What is the ratio of the Imports(as % of merchandise exports) in Malawi in 2005 to that in 2006?
Offer a terse response. 1.18. What is the ratio of the Imports(as % of merchandise exports) of Pakistan in 2005 to that in 2006?
Your answer should be very brief. 1.09. What is the ratio of the Imports(as % of merchandise exports) in Bulgaria in 2005 to that in 2007?
Ensure brevity in your answer.  0.75. What is the ratio of the Imports(as % of merchandise exports) of France in 2005 to that in 2007?
Offer a terse response. 0.75. What is the ratio of the Imports(as % of merchandise exports) of Malawi in 2005 to that in 2007?
Your answer should be compact. 1.23. What is the ratio of the Imports(as % of merchandise exports) in Pakistan in 2005 to that in 2007?
Your response must be concise. 0.91. What is the ratio of the Imports(as % of merchandise exports) in Bulgaria in 2005 to that in 2008?
Offer a very short reply. 0.86. What is the ratio of the Imports(as % of merchandise exports) in France in 2005 to that in 2008?
Provide a succinct answer. 0.85. What is the ratio of the Imports(as % of merchandise exports) in Malawi in 2005 to that in 2008?
Offer a terse response. 1.51. What is the ratio of the Imports(as % of merchandise exports) in Pakistan in 2005 to that in 2008?
Your response must be concise. 1.09. What is the ratio of the Imports(as % of merchandise exports) of France in 2005 to that in 2009?
Your response must be concise. 1.21. What is the ratio of the Imports(as % of merchandise exports) in Malawi in 2005 to that in 2009?
Make the answer very short. 0.89. What is the ratio of the Imports(as % of merchandise exports) in Pakistan in 2005 to that in 2009?
Make the answer very short. 0.92. What is the ratio of the Imports(as % of merchandise exports) in Bulgaria in 2005 to that in 2010?
Provide a short and direct response. 0.73. What is the ratio of the Imports(as % of merchandise exports) of France in 2005 to that in 2010?
Your response must be concise. 0.94. What is the ratio of the Imports(as % of merchandise exports) in Malawi in 2005 to that in 2010?
Keep it short and to the point. 0.84. What is the ratio of the Imports(as % of merchandise exports) in Pakistan in 2005 to that in 2010?
Your answer should be compact. 1.14. What is the ratio of the Imports(as % of merchandise exports) in Bulgaria in 2005 to that in 2011?
Provide a succinct answer. 0.63. What is the ratio of the Imports(as % of merchandise exports) of France in 2005 to that in 2011?
Give a very brief answer. 0.89. What is the ratio of the Imports(as % of merchandise exports) in Malawi in 2005 to that in 2011?
Your answer should be compact. 0.31. What is the ratio of the Imports(as % of merchandise exports) in Pakistan in 2005 to that in 2011?
Your answer should be very brief. 1.21. What is the ratio of the Imports(as % of merchandise exports) in Bulgaria in 2006 to that in 2007?
Make the answer very short. 1.01. What is the ratio of the Imports(as % of merchandise exports) in France in 2006 to that in 2007?
Your response must be concise. 0.99. What is the ratio of the Imports(as % of merchandise exports) in Malawi in 2006 to that in 2007?
Give a very brief answer. 1.04. What is the ratio of the Imports(as % of merchandise exports) in Pakistan in 2006 to that in 2007?
Provide a short and direct response. 0.83. What is the ratio of the Imports(as % of merchandise exports) of Bulgaria in 2006 to that in 2008?
Provide a succinct answer. 1.15. What is the ratio of the Imports(as % of merchandise exports) in France in 2006 to that in 2008?
Your answer should be very brief. 1.12. What is the ratio of the Imports(as % of merchandise exports) of Malawi in 2006 to that in 2008?
Give a very brief answer. 1.28. What is the ratio of the Imports(as % of merchandise exports) of Pakistan in 2006 to that in 2008?
Provide a short and direct response. 1.01. What is the ratio of the Imports(as % of merchandise exports) of Bulgaria in 2006 to that in 2009?
Provide a short and direct response. 1.33. What is the ratio of the Imports(as % of merchandise exports) in France in 2006 to that in 2009?
Your answer should be very brief. 1.59. What is the ratio of the Imports(as % of merchandise exports) in Malawi in 2006 to that in 2009?
Ensure brevity in your answer.  0.76. What is the ratio of the Imports(as % of merchandise exports) in Pakistan in 2006 to that in 2009?
Offer a very short reply. 0.84. What is the ratio of the Imports(as % of merchandise exports) of France in 2006 to that in 2010?
Make the answer very short. 1.23. What is the ratio of the Imports(as % of merchandise exports) in Malawi in 2006 to that in 2010?
Your answer should be very brief. 0.71. What is the ratio of the Imports(as % of merchandise exports) in Pakistan in 2006 to that in 2010?
Keep it short and to the point. 1.05. What is the ratio of the Imports(as % of merchandise exports) of Bulgaria in 2006 to that in 2011?
Keep it short and to the point. 0.84. What is the ratio of the Imports(as % of merchandise exports) of France in 2006 to that in 2011?
Offer a terse response. 1.17. What is the ratio of the Imports(as % of merchandise exports) of Malawi in 2006 to that in 2011?
Ensure brevity in your answer.  0.26. What is the ratio of the Imports(as % of merchandise exports) of Pakistan in 2006 to that in 2011?
Provide a succinct answer. 1.12. What is the ratio of the Imports(as % of merchandise exports) in Bulgaria in 2007 to that in 2008?
Make the answer very short. 1.15. What is the ratio of the Imports(as % of merchandise exports) of France in 2007 to that in 2008?
Keep it short and to the point. 1.14. What is the ratio of the Imports(as % of merchandise exports) in Malawi in 2007 to that in 2008?
Give a very brief answer. 1.23. What is the ratio of the Imports(as % of merchandise exports) of Pakistan in 2007 to that in 2008?
Your response must be concise. 1.21. What is the ratio of the Imports(as % of merchandise exports) of Bulgaria in 2007 to that in 2009?
Provide a succinct answer. 1.33. What is the ratio of the Imports(as % of merchandise exports) of France in 2007 to that in 2009?
Your answer should be very brief. 1.61. What is the ratio of the Imports(as % of merchandise exports) of Malawi in 2007 to that in 2009?
Your response must be concise. 0.73. What is the ratio of the Imports(as % of merchandise exports) of Pakistan in 2007 to that in 2009?
Provide a succinct answer. 1.01. What is the ratio of the Imports(as % of merchandise exports) of Bulgaria in 2007 to that in 2010?
Give a very brief answer. 0.98. What is the ratio of the Imports(as % of merchandise exports) in France in 2007 to that in 2010?
Provide a succinct answer. 1.25. What is the ratio of the Imports(as % of merchandise exports) in Malawi in 2007 to that in 2010?
Provide a short and direct response. 0.68. What is the ratio of the Imports(as % of merchandise exports) in Pakistan in 2007 to that in 2010?
Offer a terse response. 1.26. What is the ratio of the Imports(as % of merchandise exports) in Bulgaria in 2007 to that in 2011?
Offer a terse response. 0.84. What is the ratio of the Imports(as % of merchandise exports) in France in 2007 to that in 2011?
Provide a succinct answer. 1.19. What is the ratio of the Imports(as % of merchandise exports) of Malawi in 2007 to that in 2011?
Your answer should be compact. 0.25. What is the ratio of the Imports(as % of merchandise exports) of Pakistan in 2007 to that in 2011?
Offer a terse response. 1.34. What is the ratio of the Imports(as % of merchandise exports) of Bulgaria in 2008 to that in 2009?
Make the answer very short. 1.16. What is the ratio of the Imports(as % of merchandise exports) of France in 2008 to that in 2009?
Your response must be concise. 1.42. What is the ratio of the Imports(as % of merchandise exports) in Malawi in 2008 to that in 2009?
Make the answer very short. 0.59. What is the ratio of the Imports(as % of merchandise exports) of Pakistan in 2008 to that in 2009?
Provide a short and direct response. 0.84. What is the ratio of the Imports(as % of merchandise exports) in Bulgaria in 2008 to that in 2010?
Your response must be concise. 0.86. What is the ratio of the Imports(as % of merchandise exports) of France in 2008 to that in 2010?
Offer a very short reply. 1.1. What is the ratio of the Imports(as % of merchandise exports) of Malawi in 2008 to that in 2010?
Provide a succinct answer. 0.55. What is the ratio of the Imports(as % of merchandise exports) in Pakistan in 2008 to that in 2010?
Make the answer very short. 1.04. What is the ratio of the Imports(as % of merchandise exports) in Bulgaria in 2008 to that in 2011?
Keep it short and to the point. 0.73. What is the ratio of the Imports(as % of merchandise exports) of France in 2008 to that in 2011?
Your answer should be very brief. 1.05. What is the ratio of the Imports(as % of merchandise exports) of Malawi in 2008 to that in 2011?
Provide a short and direct response. 0.2. What is the ratio of the Imports(as % of merchandise exports) in Pakistan in 2008 to that in 2011?
Make the answer very short. 1.11. What is the ratio of the Imports(as % of merchandise exports) of Bulgaria in 2009 to that in 2010?
Offer a very short reply. 0.74. What is the ratio of the Imports(as % of merchandise exports) in France in 2009 to that in 2010?
Offer a very short reply. 0.78. What is the ratio of the Imports(as % of merchandise exports) of Malawi in 2009 to that in 2010?
Offer a very short reply. 0.94. What is the ratio of the Imports(as % of merchandise exports) of Pakistan in 2009 to that in 2010?
Ensure brevity in your answer.  1.25. What is the ratio of the Imports(as % of merchandise exports) in Bulgaria in 2009 to that in 2011?
Your response must be concise. 0.63. What is the ratio of the Imports(as % of merchandise exports) in France in 2009 to that in 2011?
Provide a short and direct response. 0.74. What is the ratio of the Imports(as % of merchandise exports) of Malawi in 2009 to that in 2011?
Give a very brief answer. 0.34. What is the ratio of the Imports(as % of merchandise exports) of Pakistan in 2009 to that in 2011?
Provide a succinct answer. 1.32. What is the ratio of the Imports(as % of merchandise exports) in Bulgaria in 2010 to that in 2011?
Offer a terse response. 0.85. What is the ratio of the Imports(as % of merchandise exports) in France in 2010 to that in 2011?
Offer a terse response. 0.95. What is the ratio of the Imports(as % of merchandise exports) in Malawi in 2010 to that in 2011?
Make the answer very short. 0.37. What is the ratio of the Imports(as % of merchandise exports) in Pakistan in 2010 to that in 2011?
Keep it short and to the point. 1.06. What is the difference between the highest and the second highest Imports(as % of merchandise exports) in Bulgaria?
Provide a succinct answer. 1.54. What is the difference between the highest and the second highest Imports(as % of merchandise exports) in France?
Offer a very short reply. 0.05. What is the difference between the highest and the second highest Imports(as % of merchandise exports) of Malawi?
Ensure brevity in your answer.  1.76. What is the difference between the highest and the second highest Imports(as % of merchandise exports) in Pakistan?
Provide a succinct answer. 0.04. What is the difference between the highest and the lowest Imports(as % of merchandise exports) in Bulgaria?
Ensure brevity in your answer.  3.94. What is the difference between the highest and the lowest Imports(as % of merchandise exports) of France?
Keep it short and to the point. 1.33. What is the difference between the highest and the lowest Imports(as % of merchandise exports) in Malawi?
Give a very brief answer. 2.22. What is the difference between the highest and the lowest Imports(as % of merchandise exports) in Pakistan?
Give a very brief answer. 0.95. 